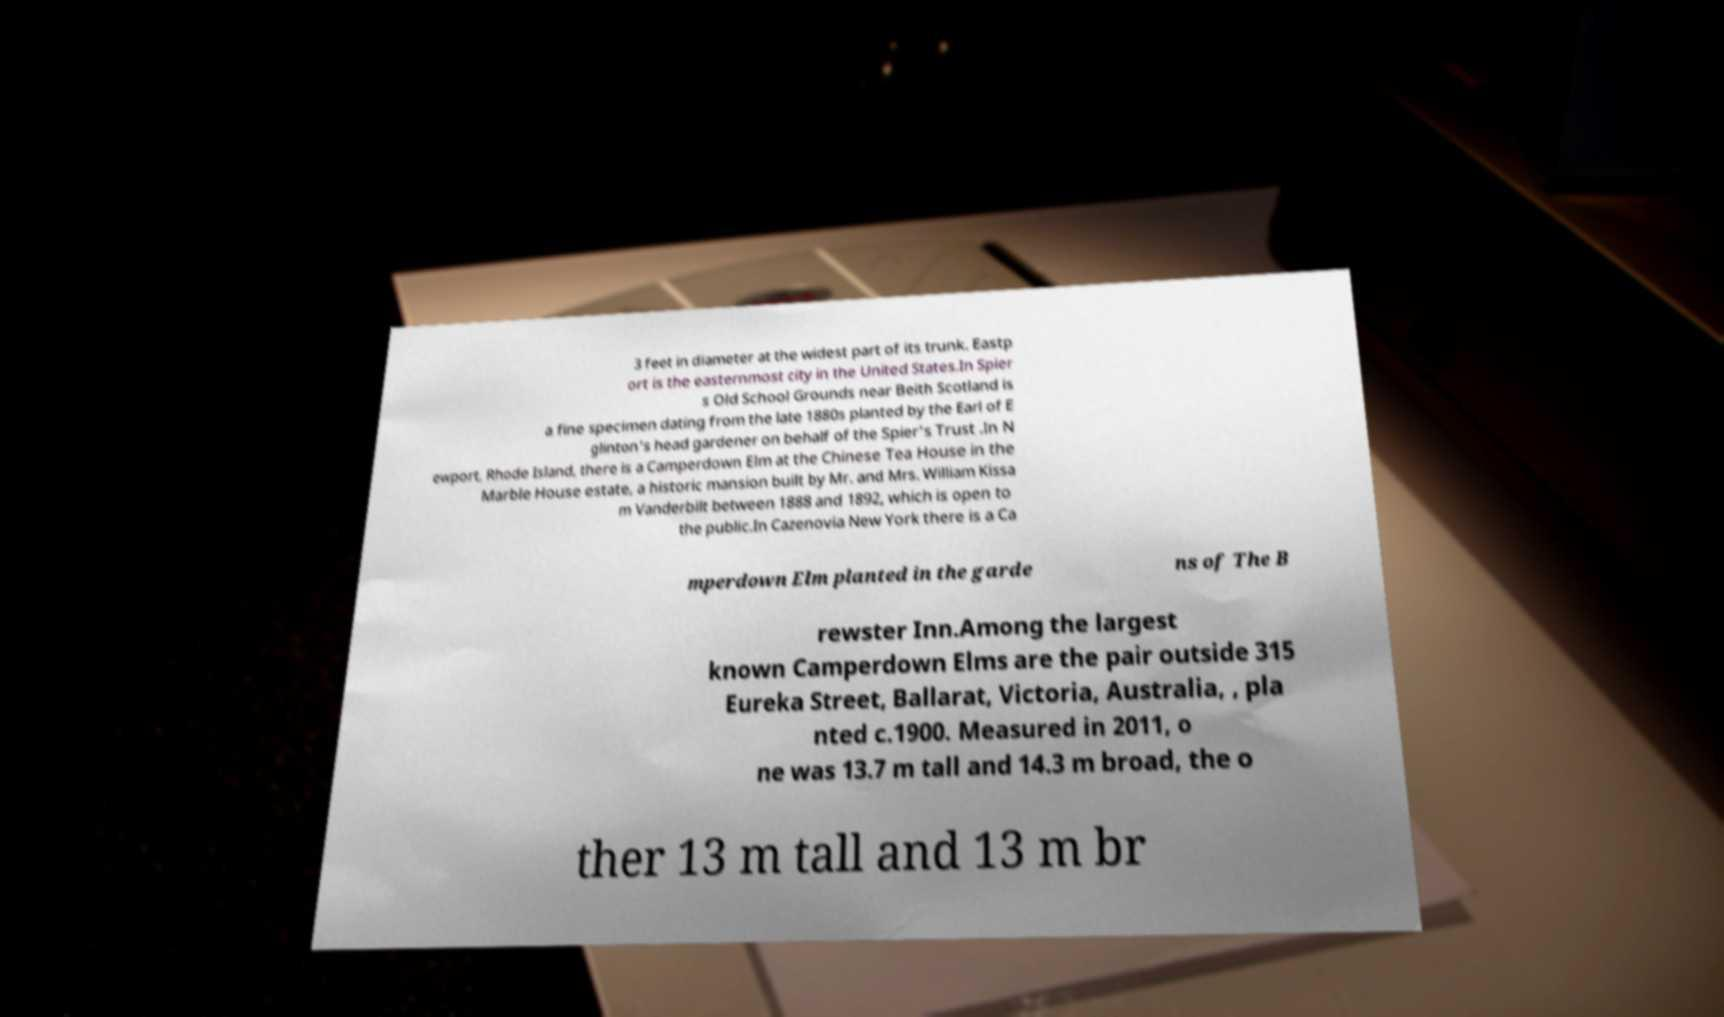Please read and relay the text visible in this image. What does it say? 3 feet in diameter at the widest part of its trunk. Eastp ort is the easternmost city in the United States.In Spier s Old School Grounds near Beith Scotland is a fine specimen dating from the late 1880s planted by the Earl of E glinton's head gardener on behalf of the Spier's Trust .In N ewport, Rhode Island, there is a Camperdown Elm at the Chinese Tea House in the Marble House estate, a historic mansion built by Mr. and Mrs. William Kissa m Vanderbilt between 1888 and 1892, which is open to the public.In Cazenovia New York there is a Ca mperdown Elm planted in the garde ns of The B rewster Inn.Among the largest known Camperdown Elms are the pair outside 315 Eureka Street, Ballarat, Victoria, Australia, , pla nted c.1900. Measured in 2011, o ne was 13.7 m tall and 14.3 m broad, the o ther 13 m tall and 13 m br 